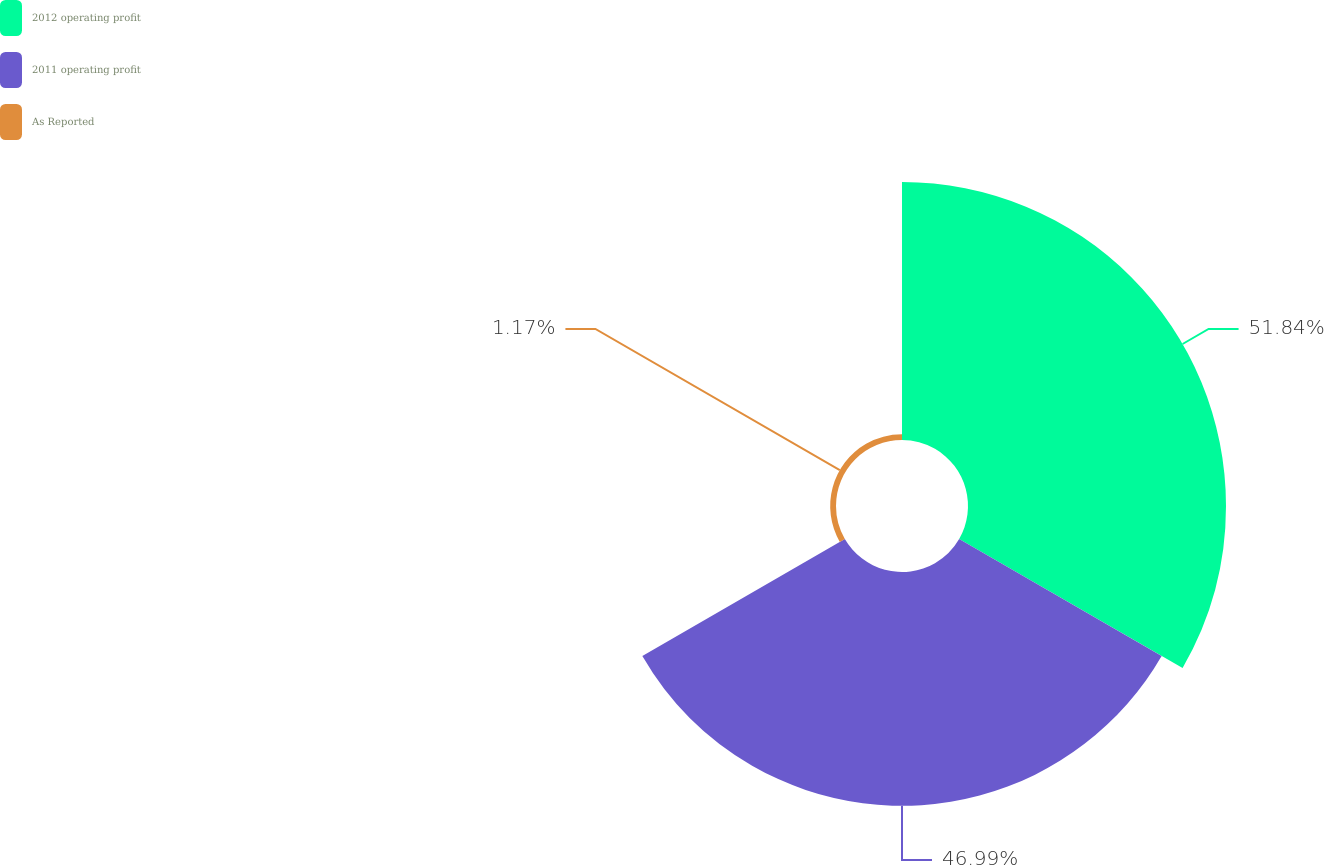Convert chart. <chart><loc_0><loc_0><loc_500><loc_500><pie_chart><fcel>2012 operating profit<fcel>2011 operating profit<fcel>As Reported<nl><fcel>51.85%<fcel>46.99%<fcel>1.17%<nl></chart> 